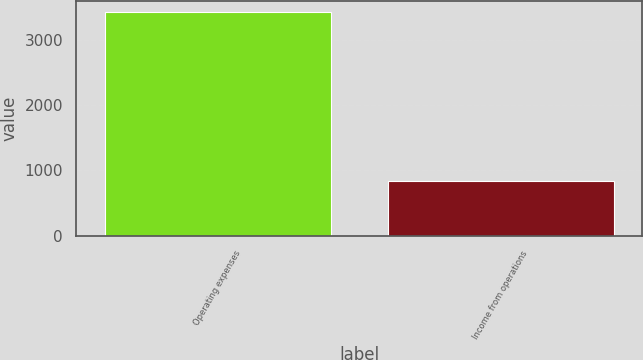Convert chart to OTSL. <chart><loc_0><loc_0><loc_500><loc_500><bar_chart><fcel>Operating expenses<fcel>Income from operations<nl><fcel>3428<fcel>842<nl></chart> 